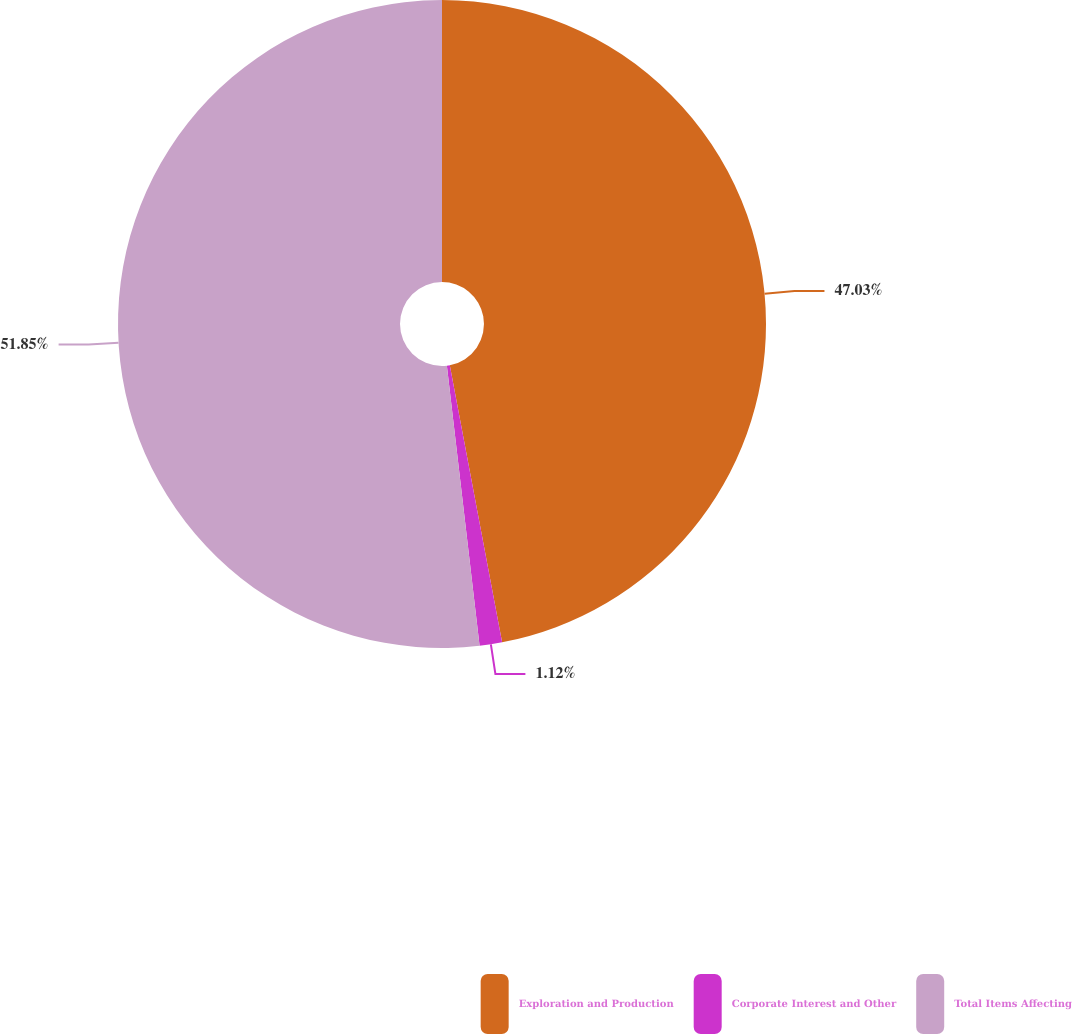Convert chart to OTSL. <chart><loc_0><loc_0><loc_500><loc_500><pie_chart><fcel>Exploration and Production<fcel>Corporate Interest and Other<fcel>Total Items Affecting<nl><fcel>47.03%<fcel>1.12%<fcel>51.85%<nl></chart> 